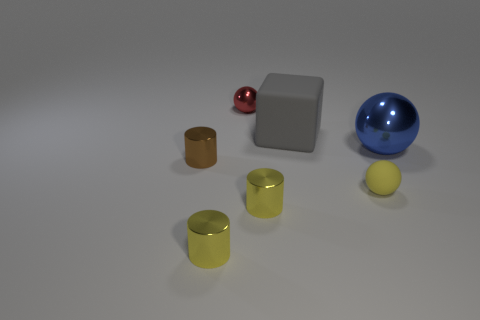Is there a small shiny thing that has the same color as the matte sphere?
Your answer should be very brief. Yes. Is there any other thing of the same color as the rubber cube?
Offer a very short reply. No. What color is the ball left of the small matte sphere?
Make the answer very short. Red. Do the tiny cylinder right of the red shiny object and the tiny matte ball have the same color?
Make the answer very short. Yes. There is a tiny red thing that is the same shape as the blue object; what material is it?
Provide a short and direct response. Metal. What number of other matte objects are the same size as the blue thing?
Your answer should be very brief. 1. There is a gray rubber object; what shape is it?
Give a very brief answer. Cube. What size is the ball that is both behind the yellow ball and in front of the gray rubber thing?
Provide a succinct answer. Large. There is a small object on the right side of the big gray rubber cube; what is it made of?
Your answer should be compact. Rubber. There is a tiny matte sphere; is its color the same as the cylinder that is to the right of the small red shiny object?
Offer a very short reply. Yes. 